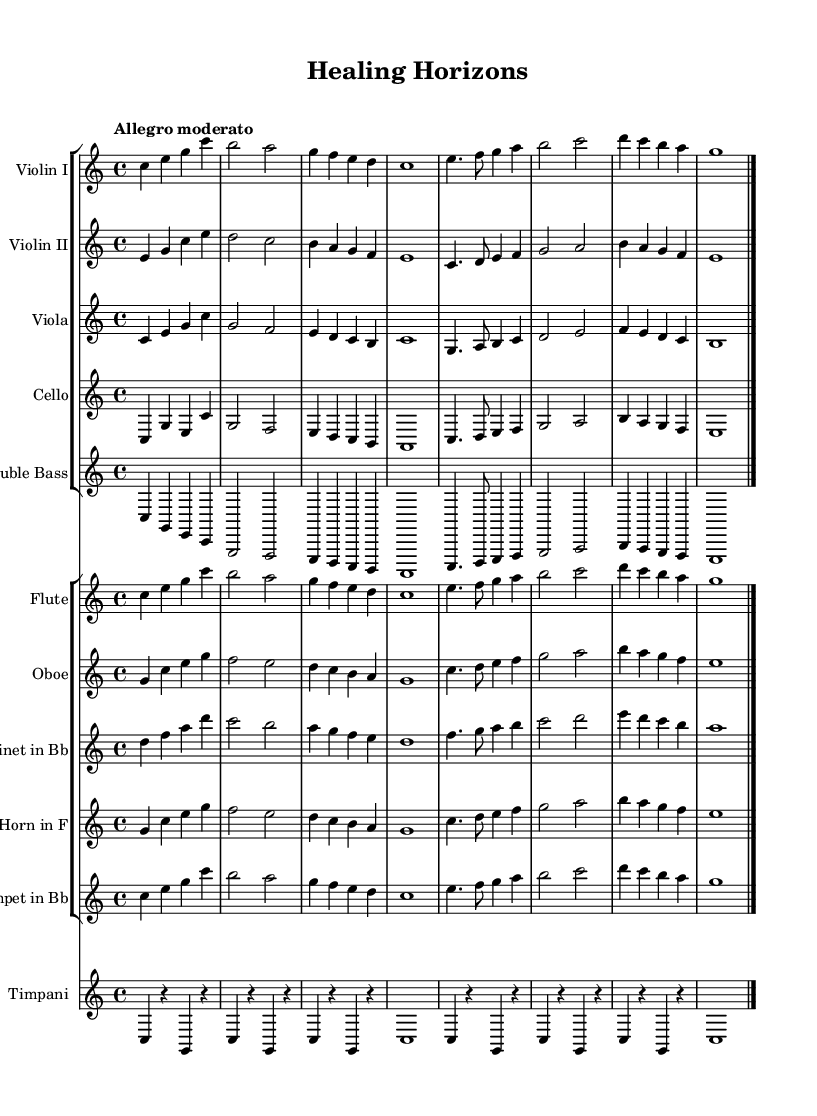What is the title of this composition? The title "Healing Horizons" is indicated in the header section of the sheet music.
Answer: Healing Horizons What is the time signature of this piece? The time signature is indicated at the beginning of the score. It shows that there are four beats in each measure, denoted as 4/4.
Answer: 4/4 What is the tempo marking of this composition? The tempo marking "Allegro moderato" is specified in the global section of the sheet music, indicating a moderate fast pace.
Answer: Allegro moderato Which instruments are included in the orchestration? The sheet music indicates various instruments, including violin I, violin II, viola, cello, double bass, and woodwinds like flute, oboe, clarinet, horn, and trumpet, along with timpani.
Answer: Violin I, Violin II, Viola, Cello, Double Bass, Flute, Oboe, Clarinet, Horn, Trumpet, Timpani How many movements does this piece contain? The structure of the sheet music suggests a single movement without indication of separate sections or movements, typically found in orchestral works.
Answer: 1 In what key is this composition written? The key signature is shown at the beginning, indicating that the piece is in C major, which has no sharps or flats.
Answer: C major What is the instrumentation for the strings section? The strings section is composed of Violin I, Violin II, Viola, Cello, and Double Bass, as indicated in the staff groups at the left of the score.
Answer: Violin I, Violin II, Viola, Cello, Double Bass 